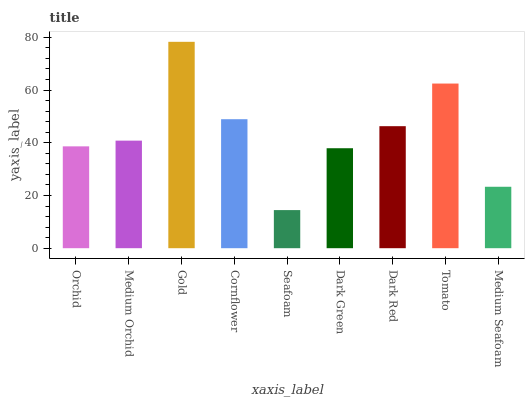Is Seafoam the minimum?
Answer yes or no. Yes. Is Gold the maximum?
Answer yes or no. Yes. Is Medium Orchid the minimum?
Answer yes or no. No. Is Medium Orchid the maximum?
Answer yes or no. No. Is Medium Orchid greater than Orchid?
Answer yes or no. Yes. Is Orchid less than Medium Orchid?
Answer yes or no. Yes. Is Orchid greater than Medium Orchid?
Answer yes or no. No. Is Medium Orchid less than Orchid?
Answer yes or no. No. Is Medium Orchid the high median?
Answer yes or no. Yes. Is Medium Orchid the low median?
Answer yes or no. Yes. Is Seafoam the high median?
Answer yes or no. No. Is Gold the low median?
Answer yes or no. No. 